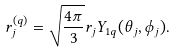Convert formula to latex. <formula><loc_0><loc_0><loc_500><loc_500>r _ { j } ^ { ( q ) } = \sqrt { \frac { 4 \pi } { 3 } } r _ { j } Y _ { 1 q } ( \theta _ { j } , \phi _ { j } ) .</formula> 